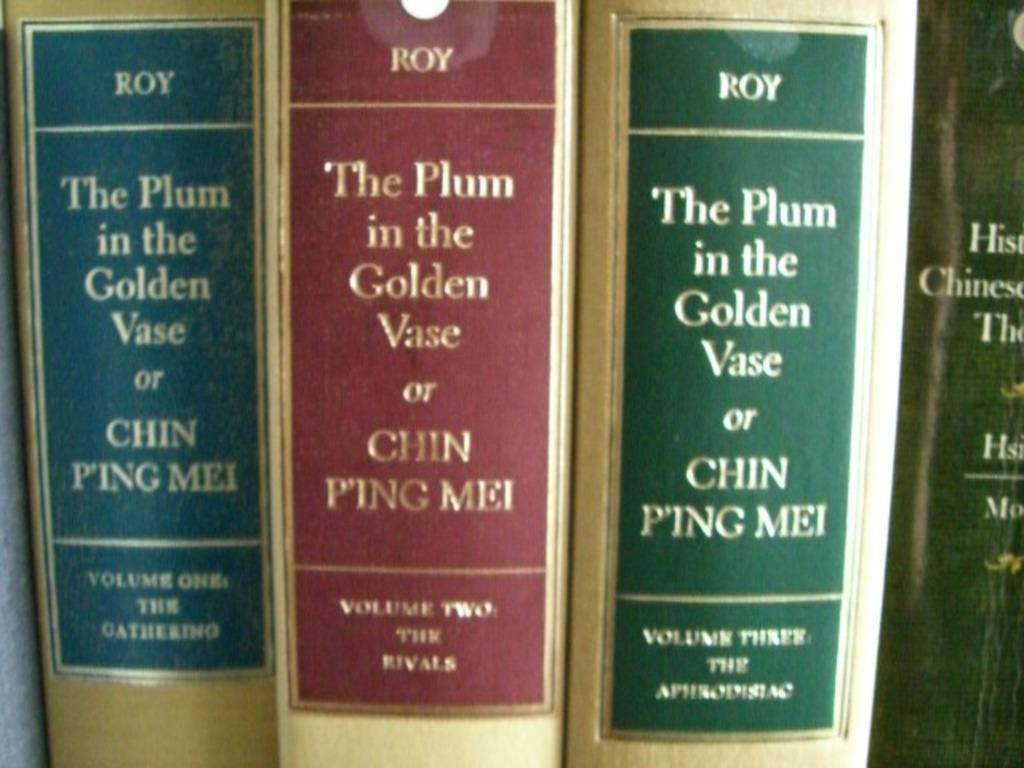<image>
Present a compact description of the photo's key features. a row of books that say roy at the top of all of them 